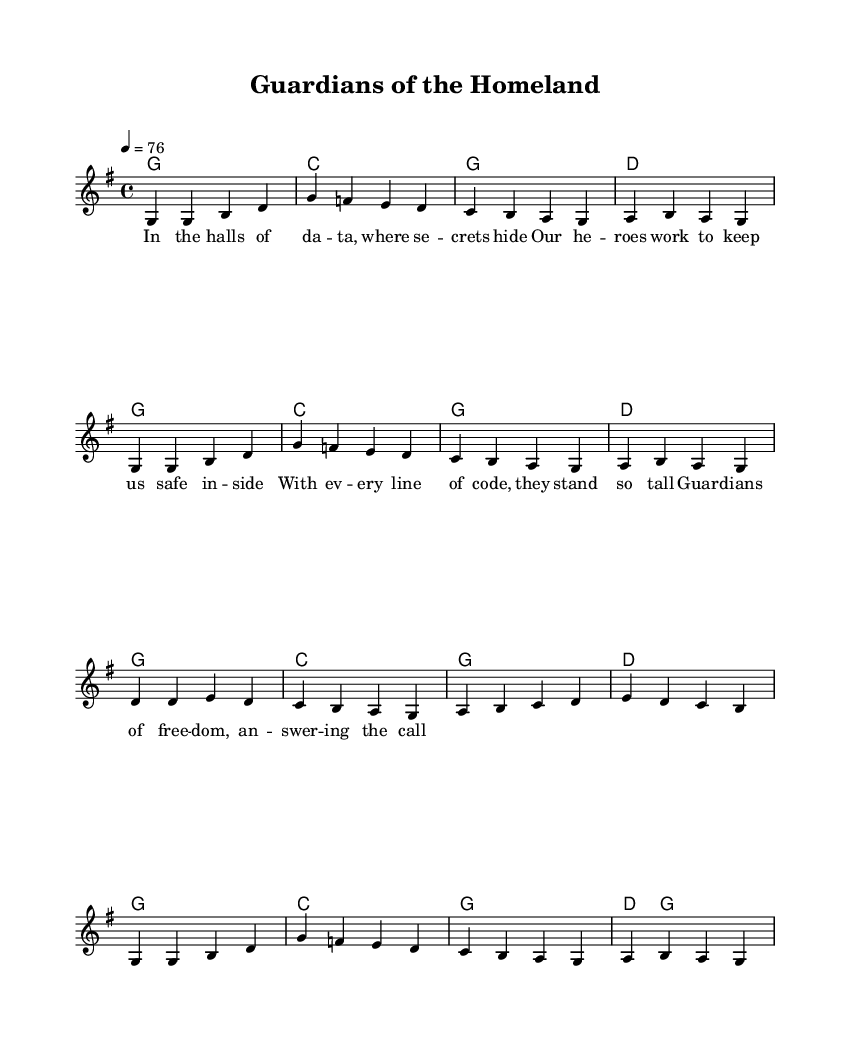What is the key signature of this music? The key signature indicated at the beginning of the sheet music is G major, which typically has one sharp (F#). This can be identified from the key signature marking found at the start of the score.
Answer: G major What is the time signature of this music? The time signature shown in the sheet music is 4/4, meaning there are four beats in a measure and the quarter note gets the beat. This is evident from the time signature marking placed at the beginning of the score.
Answer: 4/4 What is the tempo marking in this music? The tempo marking specifies a tempo of 76 beats per minute, which indicates the speed at which the piece should be played. This is clearly listed next to the tempo instruction at the start of the score.
Answer: 76 How many measures are in the melody section? By counting the individual measures in the melody part, which are divided by vertical bar lines, we see that there are 12 measures in the melody section. This requires visual inspection of the notation representing the melody line.
Answer: 12 What is the main theme of the lyrics? The lyrics revolve around themes of heroism and national security, celebrating the work of those who protect and serve. The "guardians of freedom" in the lyrics signify the heroes referenced in the song, focusing on their bravery and dedication. This is derived from the content of the verse presented below the melody.
Answer: Heroism What type of musical structure does this piece exhibit? This piece exhibits a simple verse structure, common in country music, wherein the lyrics are set to a repetitive melodic line. The structure can be determined by analyzing the arrangement where the melody and harmony repeat along with a fixed rhythmic pattern, typical for a ballad.
Answer: Verse structure What is one of the musical elements that enhance the patriotic theme? The choice of a strong, uplifting melody combined with the lyrics emphasizing bravery and duty enhances the patriotic theme. This is concluded by evaluating both the lyrical content and the musical characteristics that inspire feelings of pride and valor among listeners.
Answer: Melody 